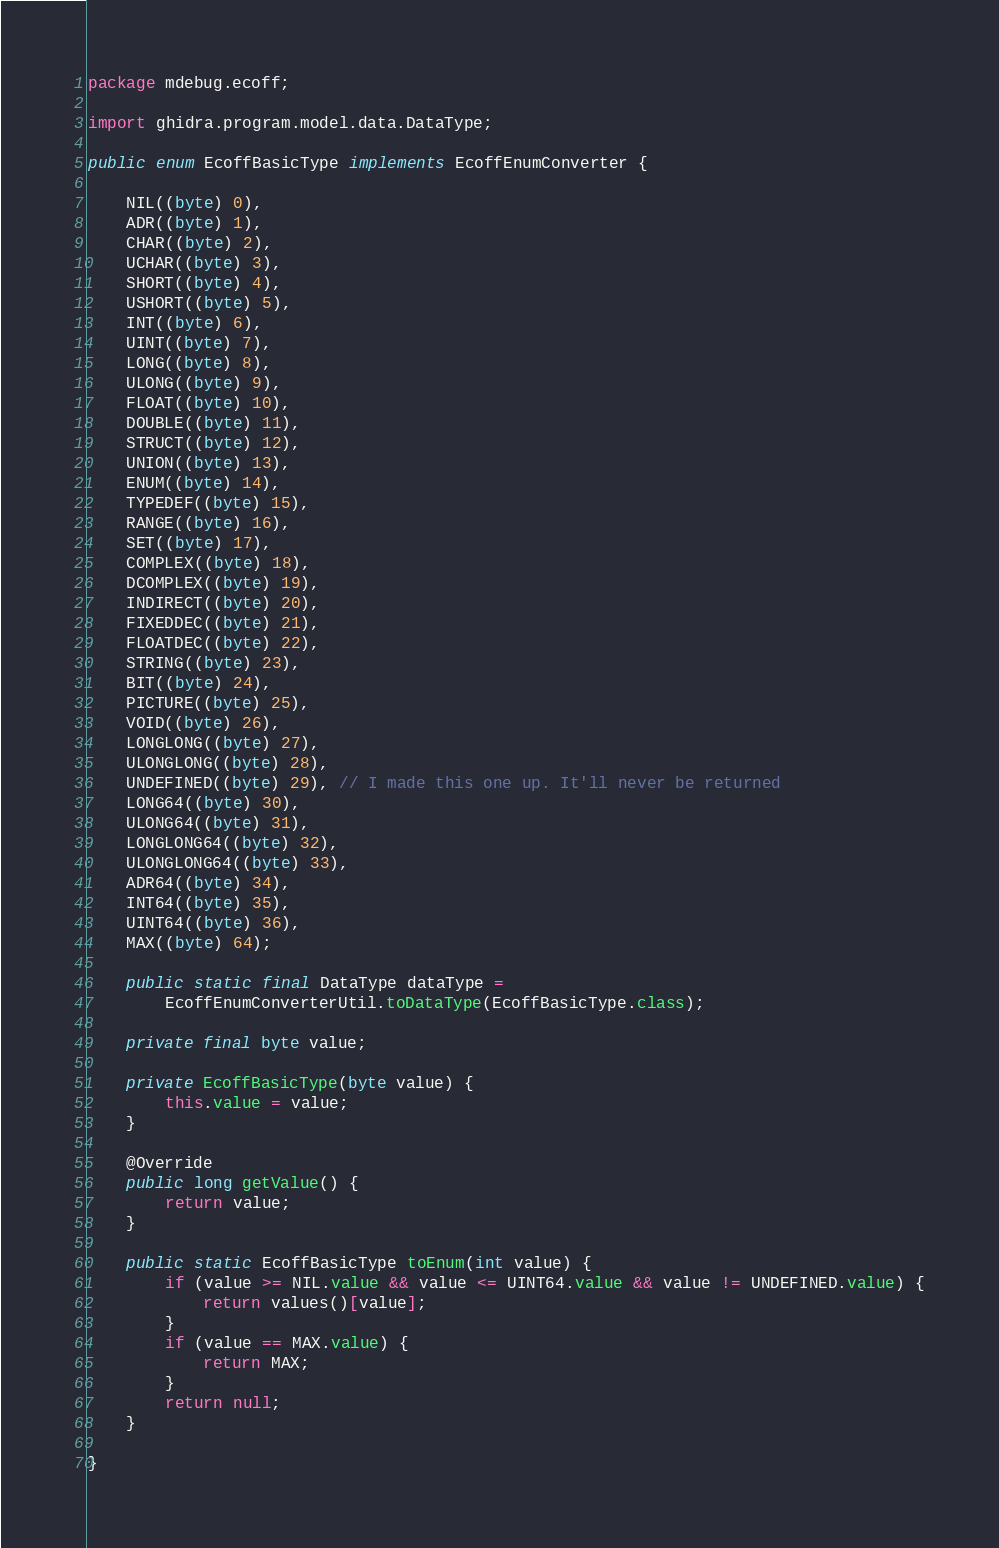Convert code to text. <code><loc_0><loc_0><loc_500><loc_500><_Java_>package mdebug.ecoff;

import ghidra.program.model.data.DataType;

public enum EcoffBasicType implements EcoffEnumConverter {
	
	NIL((byte) 0),
	ADR((byte) 1),
	CHAR((byte) 2),
	UCHAR((byte) 3),
	SHORT((byte) 4),
	USHORT((byte) 5),
	INT((byte) 6),
	UINT((byte) 7),
	LONG((byte) 8),
	ULONG((byte) 9),
	FLOAT((byte) 10),
	DOUBLE((byte) 11),
	STRUCT((byte) 12),
	UNION((byte) 13),
	ENUM((byte) 14),
	TYPEDEF((byte) 15),
	RANGE((byte) 16),
	SET((byte) 17),
	COMPLEX((byte) 18),
	DCOMPLEX((byte) 19),
	INDIRECT((byte) 20),
	FIXEDDEC((byte) 21),
	FLOATDEC((byte) 22),
	STRING((byte) 23),
	BIT((byte) 24),
	PICTURE((byte) 25),
	VOID((byte) 26),
	LONGLONG((byte) 27),
	ULONGLONG((byte) 28),
	UNDEFINED((byte) 29), // I made this one up. It'll never be returned
	LONG64((byte) 30),
	ULONG64((byte) 31),
	LONGLONG64((byte) 32),
	ULONGLONG64((byte) 33),
	ADR64((byte) 34),
	INT64((byte) 35),
	UINT64((byte) 36),
	MAX((byte) 64);
	
	public static final DataType dataType =
		EcoffEnumConverterUtil.toDataType(EcoffBasicType.class);

	private final byte value;

	private EcoffBasicType(byte value) {
		this.value = value;
	}

	@Override
	public long getValue() {
		return value;
	}

	public static EcoffBasicType toEnum(int value) {
		if (value >= NIL.value && value <= UINT64.value && value != UNDEFINED.value) {
			return values()[value];
		}
		if (value == MAX.value) {
			return MAX;
		}
		return null;
	}
	
}
</code> 